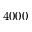Convert formula to latex. <formula><loc_0><loc_0><loc_500><loc_500>4 0 0 0</formula> 